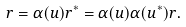Convert formula to latex. <formula><loc_0><loc_0><loc_500><loc_500>r = \alpha ( u ) r ^ { * } = \alpha ( u ) \alpha ( u ^ { * } ) r .</formula> 